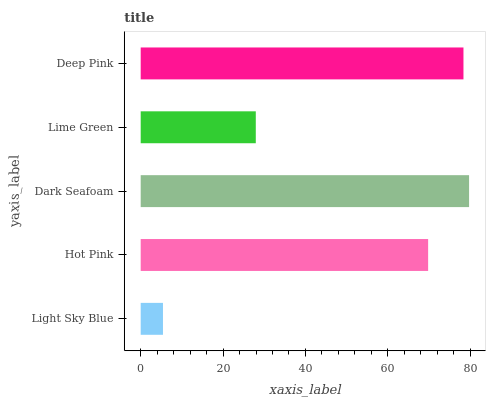Is Light Sky Blue the minimum?
Answer yes or no. Yes. Is Dark Seafoam the maximum?
Answer yes or no. Yes. Is Hot Pink the minimum?
Answer yes or no. No. Is Hot Pink the maximum?
Answer yes or no. No. Is Hot Pink greater than Light Sky Blue?
Answer yes or no. Yes. Is Light Sky Blue less than Hot Pink?
Answer yes or no. Yes. Is Light Sky Blue greater than Hot Pink?
Answer yes or no. No. Is Hot Pink less than Light Sky Blue?
Answer yes or no. No. Is Hot Pink the high median?
Answer yes or no. Yes. Is Hot Pink the low median?
Answer yes or no. Yes. Is Lime Green the high median?
Answer yes or no. No. Is Lime Green the low median?
Answer yes or no. No. 